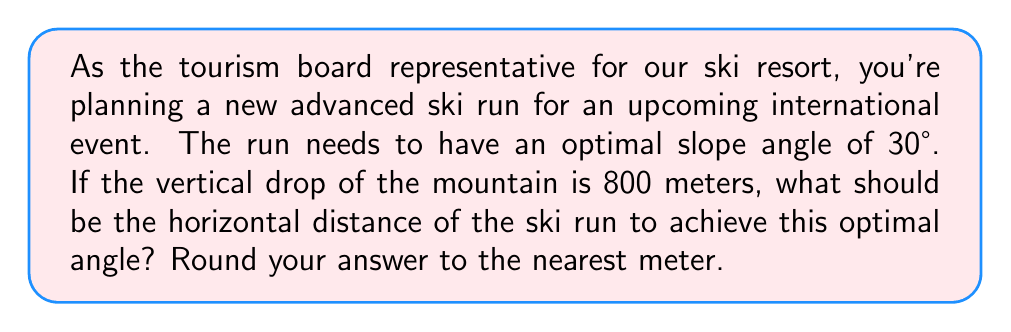Show me your answer to this math problem. Let's approach this step-by-step using trigonometric functions:

1) We can visualize the ski run as a right triangle, where:
   - The vertical drop is the opposite side
   - The horizontal distance is the adjacent side
   - The hypotenuse is the actual length of the ski run

2) We're given:
   - The angle θ = 30°
   - The opposite side (vertical drop) = 800 meters

3) We need to find the adjacent side (horizontal distance).

4) For this, we can use the tangent function:

   $$\tan θ = \frac{\text{opposite}}{\text{adjacent}}$$

5) Substituting our known values:

   $$\tan 30° = \frac{800}{\text{adjacent}}$$

6) We know that $\tan 30° = \frac{1}{\sqrt{3}}$, so:

   $$\frac{1}{\sqrt{3}} = \frac{800}{\text{adjacent}}$$

7) Cross multiply:

   $$\text{adjacent} = 800 \sqrt{3}$$

8) Calculate and round to the nearest meter:

   $$\text{adjacent} ≈ 1385.64 \text{ meters}$$

   Rounded to the nearest meter: 1386 meters

[asy]
import geometry;

size(200);

pair A = (0,0);
pair B = (10,0);
pair C = (0,5.77);

draw(A--B--C--A);

label("1386 m", (5,-0.5), S);
label("800 m", (-0.5,2.885), W);
label("30°", (0.5,0.5), NE);

draw(rightanglemark(B,A,C,2));
[/asy]
Answer: 1386 meters 